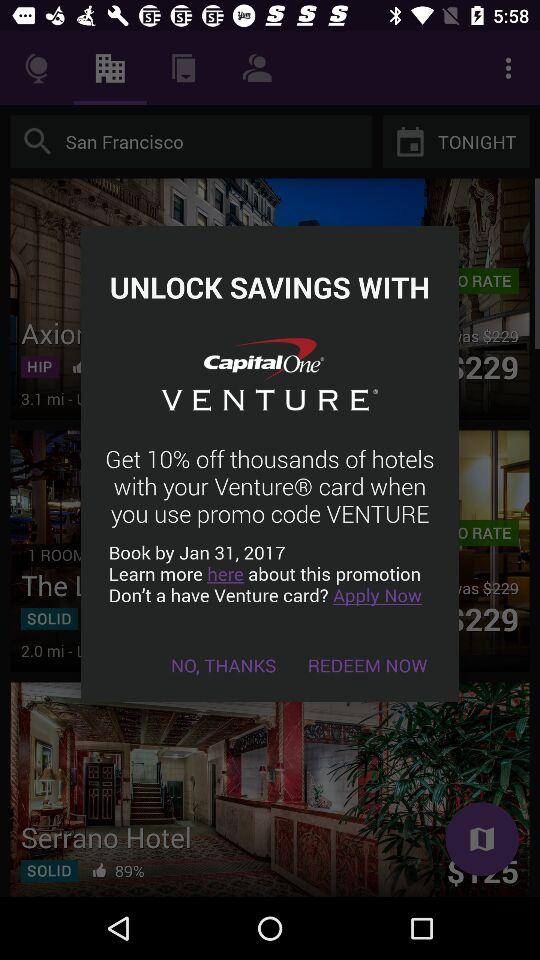By when can a hotel be booked? The hotel can be booked by January 31, 2017. 